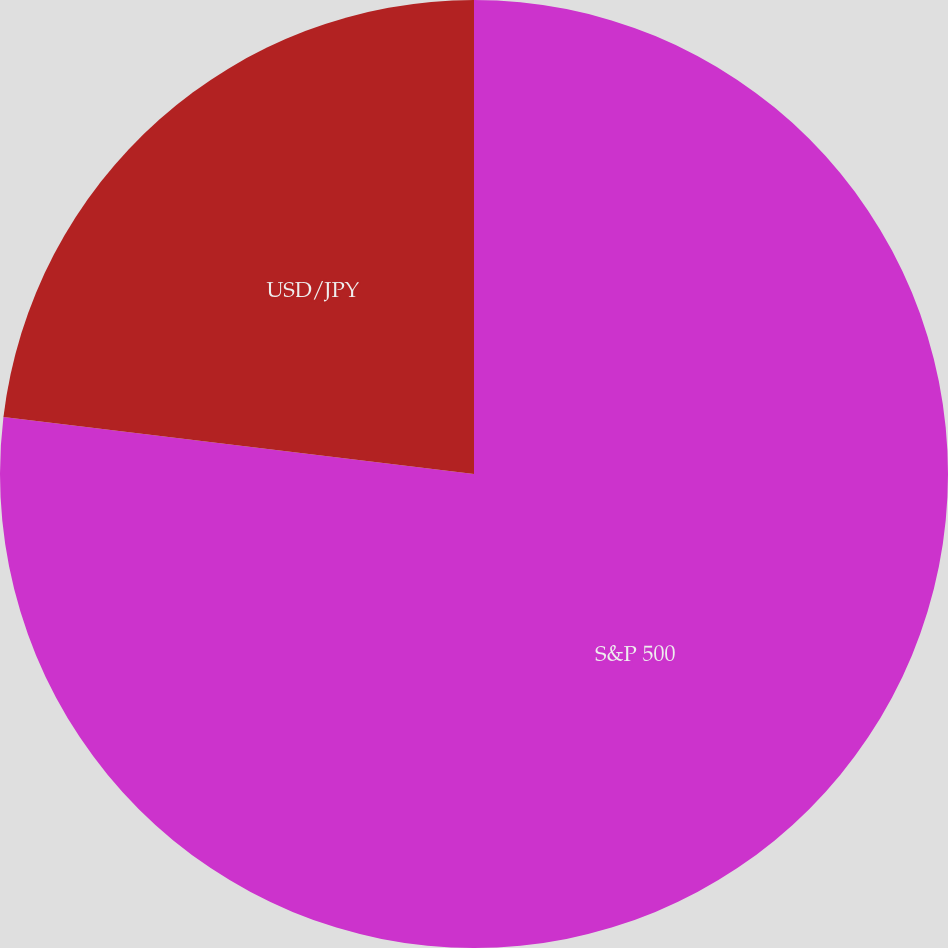Convert chart. <chart><loc_0><loc_0><loc_500><loc_500><pie_chart><fcel>S&P 500<fcel>USD/JPY<nl><fcel>76.92%<fcel>23.08%<nl></chart> 